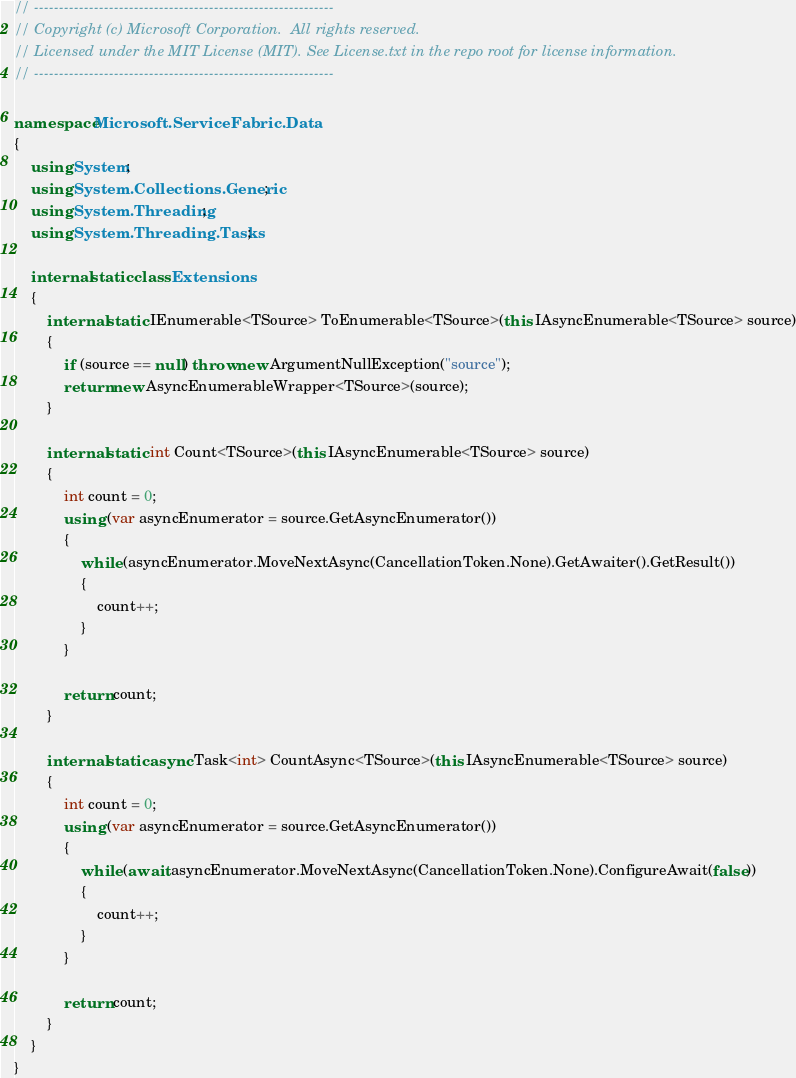Convert code to text. <code><loc_0><loc_0><loc_500><loc_500><_C#_>// ------------------------------------------------------------
// Copyright (c) Microsoft Corporation.  All rights reserved.
// Licensed under the MIT License (MIT). See License.txt in the repo root for license information.
// ------------------------------------------------------------

namespace Microsoft.ServiceFabric.Data
{
    using System;
    using System.Collections.Generic;
    using System.Threading;
    using System.Threading.Tasks;

    internal static class Extensions
    {
        internal static IEnumerable<TSource> ToEnumerable<TSource>(this IAsyncEnumerable<TSource> source)
        {
            if (source == null) throw new ArgumentNullException("source");
            return new AsyncEnumerableWrapper<TSource>(source);
        }

        internal static int Count<TSource>(this IAsyncEnumerable<TSource> source)
        {
            int count = 0;
            using (var asyncEnumerator = source.GetAsyncEnumerator())
            {
                while (asyncEnumerator.MoveNextAsync(CancellationToken.None).GetAwaiter().GetResult())
                {
                    count++;
                }
            }

            return count;
        }

        internal static async Task<int> CountAsync<TSource>(this IAsyncEnumerable<TSource> source)
        {
            int count = 0;
            using (var asyncEnumerator = source.GetAsyncEnumerator())
            {
                while (await asyncEnumerator.MoveNextAsync(CancellationToken.None).ConfigureAwait(false))
                {
                    count++;
                }
            }

            return count;
        }
    }
}</code> 